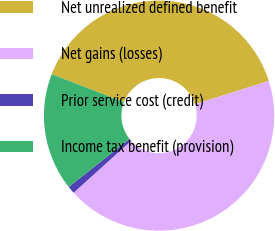Convert chart. <chart><loc_0><loc_0><loc_500><loc_500><pie_chart><fcel>Net unrealized defined benefit<fcel>Net gains (losses)<fcel>Prior service cost (credit)<fcel>Income tax benefit (provision)<nl><fcel>39.27%<fcel>43.19%<fcel>1.05%<fcel>16.49%<nl></chart> 